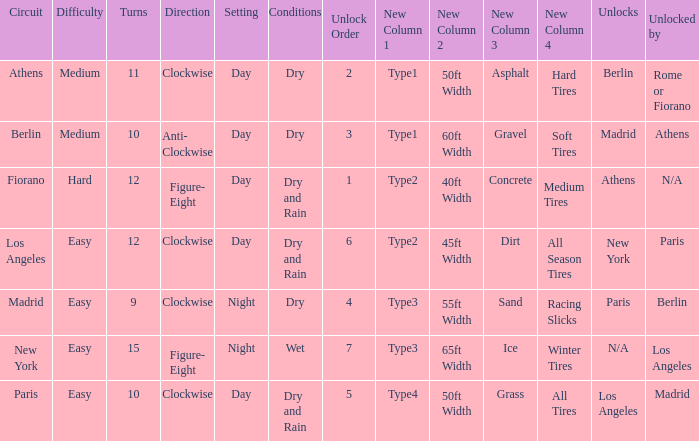What is the difficulty of the athens circuit? Medium. 